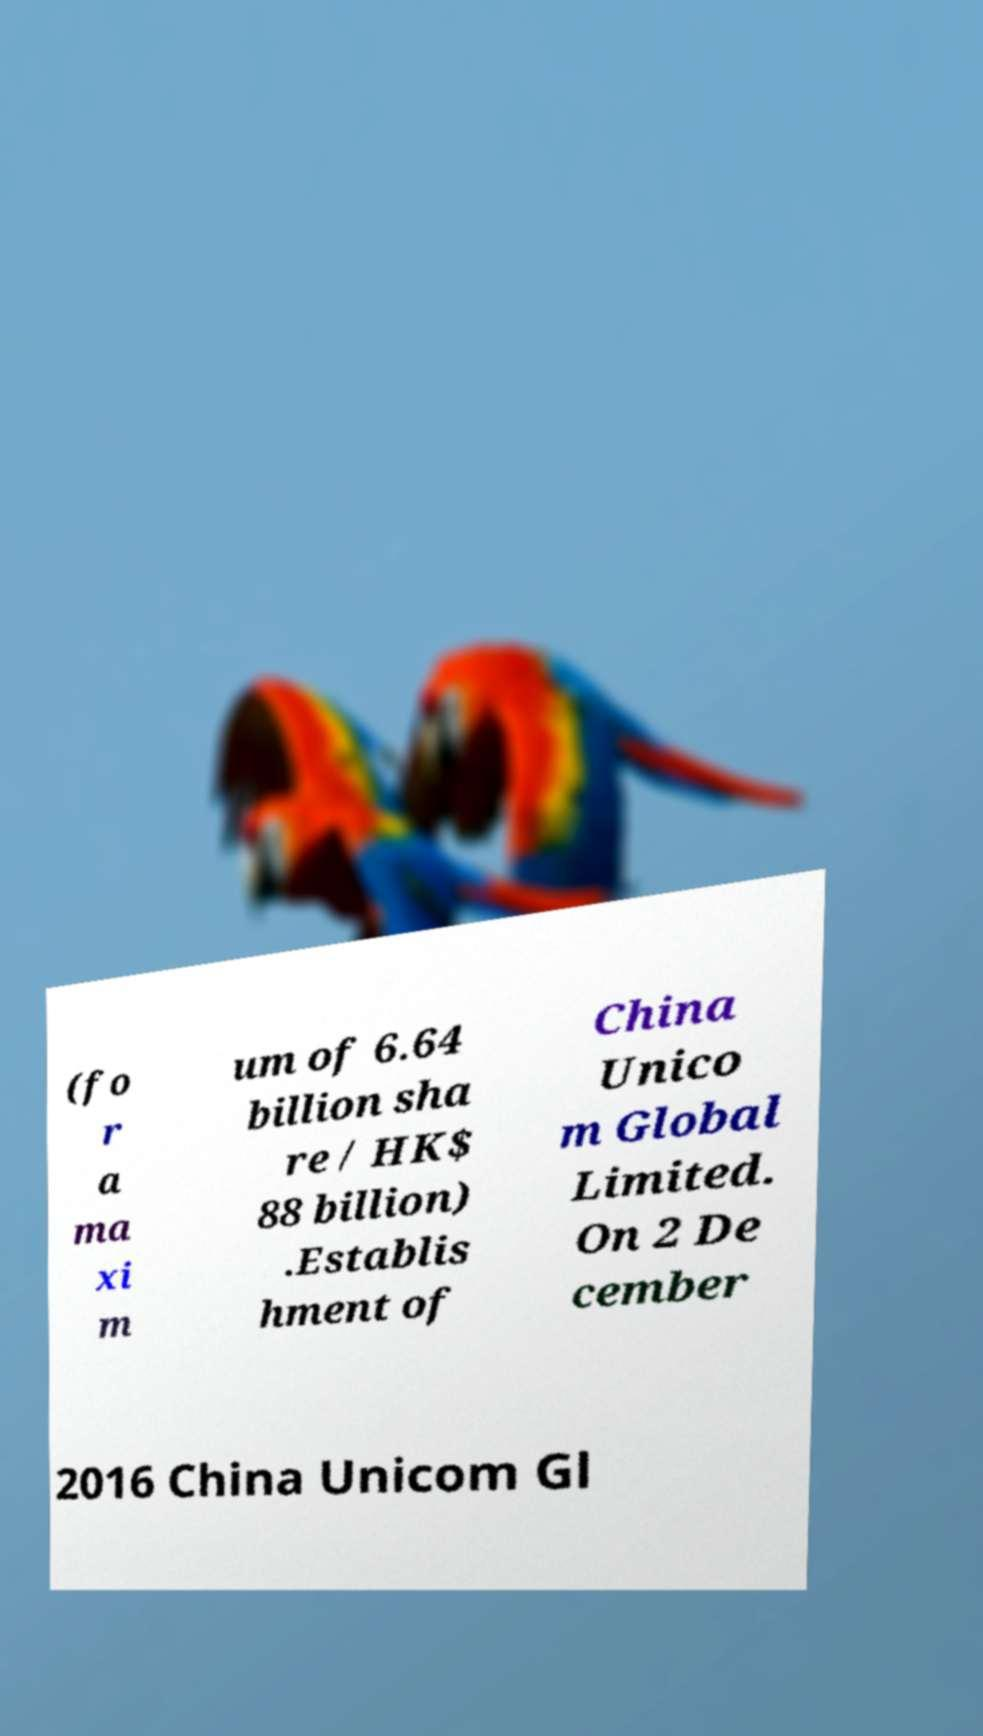Please identify and transcribe the text found in this image. (fo r a ma xi m um of 6.64 billion sha re / HK$ 88 billion) .Establis hment of China Unico m Global Limited. On 2 De cember 2016 China Unicom Gl 